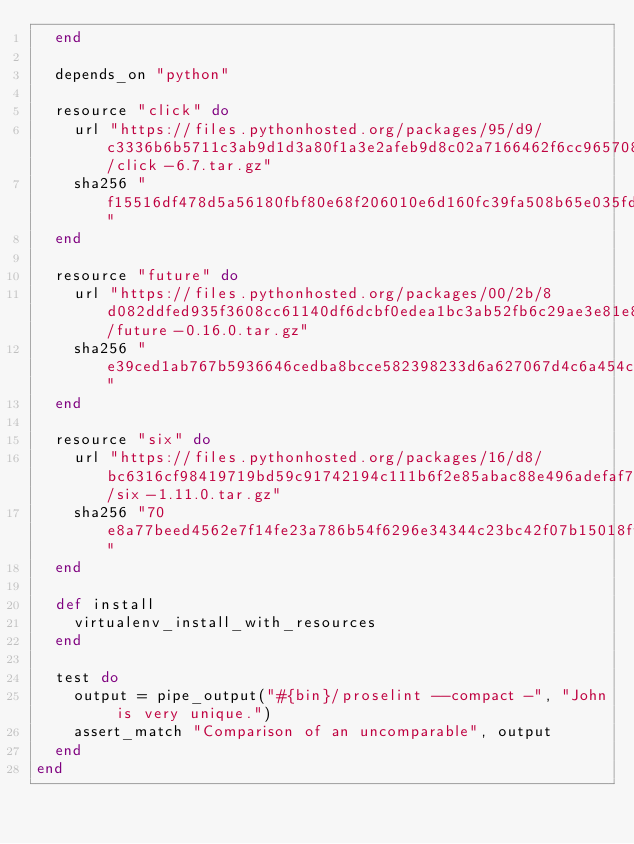<code> <loc_0><loc_0><loc_500><loc_500><_Ruby_>  end

  depends_on "python"

  resource "click" do
    url "https://files.pythonhosted.org/packages/95/d9/c3336b6b5711c3ab9d1d3a80f1a3e2afeb9d8c02a7166462f6cc96570897/click-6.7.tar.gz"
    sha256 "f15516df478d5a56180fbf80e68f206010e6d160fc39fa508b65e035fd75130b"
  end

  resource "future" do
    url "https://files.pythonhosted.org/packages/00/2b/8d082ddfed935f3608cc61140df6dcbf0edea1bc3ab52fb6c29ae3e81e85/future-0.16.0.tar.gz"
    sha256 "e39ced1ab767b5936646cedba8bcce582398233d6a627067d4c6a454c90cfedb"
  end

  resource "six" do
    url "https://files.pythonhosted.org/packages/16/d8/bc6316cf98419719bd59c91742194c111b6f2e85abac88e496adefaf7afe/six-1.11.0.tar.gz"
    sha256 "70e8a77beed4562e7f14fe23a786b54f6296e34344c23bc42f07b15018ff98e9"
  end

  def install
    virtualenv_install_with_resources
  end

  test do
    output = pipe_output("#{bin}/proselint --compact -", "John is very unique.")
    assert_match "Comparison of an uncomparable", output
  end
end
</code> 